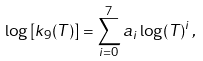<formula> <loc_0><loc_0><loc_500><loc_500>\log \left [ k _ { 9 } ( T ) \right ] = \sum _ { i = 0 } ^ { 7 } a _ { i } \log ( T ) ^ { i } \, ,</formula> 